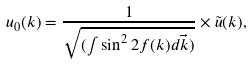<formula> <loc_0><loc_0><loc_500><loc_500>u _ { 0 } ( k ) = \frac { 1 } { \sqrt { ( \int \sin ^ { 2 } 2 f ( k ) d \vec { k } ) } } \times \tilde { u } ( k ) ,</formula> 